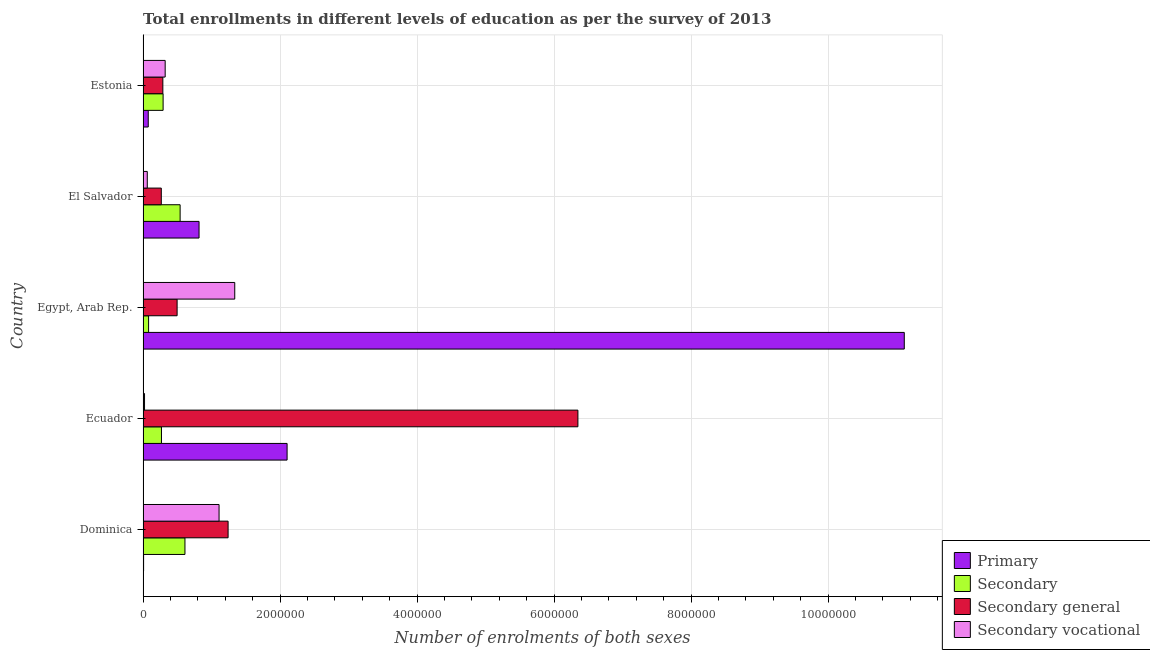Are the number of bars per tick equal to the number of legend labels?
Make the answer very short. Yes. Are the number of bars on each tick of the Y-axis equal?
Ensure brevity in your answer.  Yes. How many bars are there on the 5th tick from the bottom?
Provide a short and direct response. 4. What is the label of the 4th group of bars from the top?
Keep it short and to the point. Ecuador. What is the number of enrolments in secondary education in El Salvador?
Provide a short and direct response. 5.41e+05. Across all countries, what is the maximum number of enrolments in primary education?
Your answer should be compact. 1.11e+07. Across all countries, what is the minimum number of enrolments in secondary education?
Keep it short and to the point. 8.08e+04. In which country was the number of enrolments in secondary vocational education maximum?
Give a very brief answer. Egypt, Arab Rep. In which country was the number of enrolments in secondary education minimum?
Your response must be concise. Egypt, Arab Rep. What is the total number of enrolments in secondary general education in the graph?
Provide a short and direct response. 8.64e+06. What is the difference between the number of enrolments in primary education in Ecuador and that in Egypt, Arab Rep.?
Your answer should be compact. -9.01e+06. What is the difference between the number of enrolments in secondary vocational education in Estonia and the number of enrolments in primary education in Egypt, Arab Rep.?
Offer a terse response. -1.08e+07. What is the average number of enrolments in secondary general education per country?
Ensure brevity in your answer.  1.73e+06. What is the difference between the number of enrolments in primary education and number of enrolments in secondary vocational education in El Salvador?
Your answer should be very brief. 7.56e+05. In how many countries, is the number of enrolments in primary education greater than 8000000 ?
Your answer should be very brief. 1. What is the ratio of the number of enrolments in secondary general education in Egypt, Arab Rep. to that in El Salvador?
Provide a short and direct response. 1.87. Is the number of enrolments in secondary vocational education in Ecuador less than that in Estonia?
Your response must be concise. Yes. What is the difference between the highest and the second highest number of enrolments in secondary vocational education?
Give a very brief answer. 2.29e+05. What is the difference between the highest and the lowest number of enrolments in primary education?
Make the answer very short. 1.11e+07. In how many countries, is the number of enrolments in secondary education greater than the average number of enrolments in secondary education taken over all countries?
Offer a very short reply. 2. Is it the case that in every country, the sum of the number of enrolments in secondary education and number of enrolments in primary education is greater than the sum of number of enrolments in secondary general education and number of enrolments in secondary vocational education?
Keep it short and to the point. No. What does the 1st bar from the top in Dominica represents?
Provide a succinct answer. Secondary vocational. What does the 2nd bar from the bottom in El Salvador represents?
Provide a short and direct response. Secondary. Is it the case that in every country, the sum of the number of enrolments in primary education and number of enrolments in secondary education is greater than the number of enrolments in secondary general education?
Ensure brevity in your answer.  No. Are all the bars in the graph horizontal?
Provide a short and direct response. Yes. How many countries are there in the graph?
Make the answer very short. 5. Does the graph contain any zero values?
Your response must be concise. No. Where does the legend appear in the graph?
Provide a succinct answer. Bottom right. How many legend labels are there?
Ensure brevity in your answer.  4. How are the legend labels stacked?
Offer a terse response. Vertical. What is the title of the graph?
Give a very brief answer. Total enrollments in different levels of education as per the survey of 2013. What is the label or title of the X-axis?
Your answer should be compact. Number of enrolments of both sexes. What is the Number of enrolments of both sexes in Primary in Dominica?
Give a very brief answer. 7851. What is the Number of enrolments of both sexes of Secondary in Dominica?
Provide a succinct answer. 6.12e+05. What is the Number of enrolments of both sexes of Secondary general in Dominica?
Ensure brevity in your answer.  1.24e+06. What is the Number of enrolments of both sexes in Secondary vocational in Dominica?
Keep it short and to the point. 1.11e+06. What is the Number of enrolments of both sexes in Primary in Ecuador?
Give a very brief answer. 2.10e+06. What is the Number of enrolments of both sexes of Secondary in Ecuador?
Offer a very short reply. 2.69e+05. What is the Number of enrolments of both sexes in Secondary general in Ecuador?
Make the answer very short. 6.35e+06. What is the Number of enrolments of both sexes of Secondary vocational in Ecuador?
Offer a very short reply. 2.14e+04. What is the Number of enrolments of both sexes in Primary in Egypt, Arab Rep.?
Provide a short and direct response. 1.11e+07. What is the Number of enrolments of both sexes in Secondary in Egypt, Arab Rep.?
Provide a succinct answer. 8.08e+04. What is the Number of enrolments of both sexes in Secondary general in Egypt, Arab Rep.?
Offer a very short reply. 4.97e+05. What is the Number of enrolments of both sexes in Secondary vocational in Egypt, Arab Rep.?
Give a very brief answer. 1.34e+06. What is the Number of enrolments of both sexes of Primary in El Salvador?
Provide a short and direct response. 8.17e+05. What is the Number of enrolments of both sexes of Secondary in El Salvador?
Offer a terse response. 5.41e+05. What is the Number of enrolments of both sexes of Secondary general in El Salvador?
Keep it short and to the point. 2.66e+05. What is the Number of enrolments of both sexes in Secondary vocational in El Salvador?
Provide a succinct answer. 6.15e+04. What is the Number of enrolments of both sexes in Primary in Estonia?
Make the answer very short. 7.56e+04. What is the Number of enrolments of both sexes in Secondary in Estonia?
Your answer should be compact. 2.93e+05. What is the Number of enrolments of both sexes in Secondary general in Estonia?
Your answer should be compact. 2.89e+05. What is the Number of enrolments of both sexes in Secondary vocational in Estonia?
Provide a succinct answer. 3.23e+05. Across all countries, what is the maximum Number of enrolments of both sexes in Primary?
Your answer should be compact. 1.11e+07. Across all countries, what is the maximum Number of enrolments of both sexes of Secondary?
Offer a terse response. 6.12e+05. Across all countries, what is the maximum Number of enrolments of both sexes of Secondary general?
Offer a very short reply. 6.35e+06. Across all countries, what is the maximum Number of enrolments of both sexes of Secondary vocational?
Provide a succinct answer. 1.34e+06. Across all countries, what is the minimum Number of enrolments of both sexes of Primary?
Give a very brief answer. 7851. Across all countries, what is the minimum Number of enrolments of both sexes of Secondary?
Your answer should be very brief. 8.08e+04. Across all countries, what is the minimum Number of enrolments of both sexes in Secondary general?
Your answer should be very brief. 2.66e+05. Across all countries, what is the minimum Number of enrolments of both sexes in Secondary vocational?
Provide a succinct answer. 2.14e+04. What is the total Number of enrolments of both sexes of Primary in the graph?
Offer a terse response. 1.41e+07. What is the total Number of enrolments of both sexes of Secondary in the graph?
Provide a short and direct response. 1.79e+06. What is the total Number of enrolments of both sexes of Secondary general in the graph?
Provide a short and direct response. 8.64e+06. What is the total Number of enrolments of both sexes in Secondary vocational in the graph?
Offer a terse response. 2.85e+06. What is the difference between the Number of enrolments of both sexes in Primary in Dominica and that in Ecuador?
Your answer should be very brief. -2.09e+06. What is the difference between the Number of enrolments of both sexes of Secondary in Dominica and that in Ecuador?
Make the answer very short. 3.43e+05. What is the difference between the Number of enrolments of both sexes of Secondary general in Dominica and that in Ecuador?
Offer a terse response. -5.11e+06. What is the difference between the Number of enrolments of both sexes in Secondary vocational in Dominica and that in Ecuador?
Offer a very short reply. 1.09e+06. What is the difference between the Number of enrolments of both sexes of Primary in Dominica and that in Egypt, Arab Rep.?
Offer a very short reply. -1.11e+07. What is the difference between the Number of enrolments of both sexes of Secondary in Dominica and that in Egypt, Arab Rep.?
Offer a very short reply. 5.31e+05. What is the difference between the Number of enrolments of both sexes of Secondary general in Dominica and that in Egypt, Arab Rep.?
Offer a terse response. 7.44e+05. What is the difference between the Number of enrolments of both sexes in Secondary vocational in Dominica and that in Egypt, Arab Rep.?
Your answer should be very brief. -2.29e+05. What is the difference between the Number of enrolments of both sexes of Primary in Dominica and that in El Salvador?
Your answer should be compact. -8.09e+05. What is the difference between the Number of enrolments of both sexes in Secondary in Dominica and that in El Salvador?
Offer a very short reply. 7.06e+04. What is the difference between the Number of enrolments of both sexes of Secondary general in Dominica and that in El Salvador?
Your response must be concise. 9.75e+05. What is the difference between the Number of enrolments of both sexes of Secondary vocational in Dominica and that in El Salvador?
Provide a short and direct response. 1.05e+06. What is the difference between the Number of enrolments of both sexes of Primary in Dominica and that in Estonia?
Your response must be concise. -6.78e+04. What is the difference between the Number of enrolments of both sexes in Secondary in Dominica and that in Estonia?
Your response must be concise. 3.19e+05. What is the difference between the Number of enrolments of both sexes in Secondary general in Dominica and that in Estonia?
Your answer should be compact. 9.53e+05. What is the difference between the Number of enrolments of both sexes in Secondary vocational in Dominica and that in Estonia?
Provide a succinct answer. 7.87e+05. What is the difference between the Number of enrolments of both sexes in Primary in Ecuador and that in Egypt, Arab Rep.?
Your answer should be compact. -9.01e+06. What is the difference between the Number of enrolments of both sexes of Secondary in Ecuador and that in Egypt, Arab Rep.?
Ensure brevity in your answer.  1.88e+05. What is the difference between the Number of enrolments of both sexes of Secondary general in Ecuador and that in Egypt, Arab Rep.?
Offer a terse response. 5.85e+06. What is the difference between the Number of enrolments of both sexes of Secondary vocational in Ecuador and that in Egypt, Arab Rep.?
Your answer should be compact. -1.32e+06. What is the difference between the Number of enrolments of both sexes in Primary in Ecuador and that in El Salvador?
Offer a very short reply. 1.29e+06. What is the difference between the Number of enrolments of both sexes of Secondary in Ecuador and that in El Salvador?
Provide a short and direct response. -2.72e+05. What is the difference between the Number of enrolments of both sexes in Secondary general in Ecuador and that in El Salvador?
Provide a succinct answer. 6.08e+06. What is the difference between the Number of enrolments of both sexes of Secondary vocational in Ecuador and that in El Salvador?
Offer a terse response. -4.01e+04. What is the difference between the Number of enrolments of both sexes of Primary in Ecuador and that in Estonia?
Ensure brevity in your answer.  2.03e+06. What is the difference between the Number of enrolments of both sexes in Secondary in Ecuador and that in Estonia?
Make the answer very short. -2.40e+04. What is the difference between the Number of enrolments of both sexes in Secondary general in Ecuador and that in Estonia?
Your response must be concise. 6.06e+06. What is the difference between the Number of enrolments of both sexes of Secondary vocational in Ecuador and that in Estonia?
Make the answer very short. -3.01e+05. What is the difference between the Number of enrolments of both sexes in Primary in Egypt, Arab Rep. and that in El Salvador?
Your answer should be compact. 1.03e+07. What is the difference between the Number of enrolments of both sexes in Secondary in Egypt, Arab Rep. and that in El Salvador?
Your answer should be compact. -4.60e+05. What is the difference between the Number of enrolments of both sexes in Secondary general in Egypt, Arab Rep. and that in El Salvador?
Give a very brief answer. 2.31e+05. What is the difference between the Number of enrolments of both sexes of Secondary vocational in Egypt, Arab Rep. and that in El Salvador?
Your answer should be very brief. 1.28e+06. What is the difference between the Number of enrolments of both sexes of Primary in Egypt, Arab Rep. and that in Estonia?
Your response must be concise. 1.10e+07. What is the difference between the Number of enrolments of both sexes in Secondary in Egypt, Arab Rep. and that in Estonia?
Offer a terse response. -2.12e+05. What is the difference between the Number of enrolments of both sexes in Secondary general in Egypt, Arab Rep. and that in Estonia?
Give a very brief answer. 2.08e+05. What is the difference between the Number of enrolments of both sexes in Secondary vocational in Egypt, Arab Rep. and that in Estonia?
Offer a very short reply. 1.02e+06. What is the difference between the Number of enrolments of both sexes of Primary in El Salvador and that in Estonia?
Give a very brief answer. 7.42e+05. What is the difference between the Number of enrolments of both sexes of Secondary in El Salvador and that in Estonia?
Offer a terse response. 2.48e+05. What is the difference between the Number of enrolments of both sexes in Secondary general in El Salvador and that in Estonia?
Provide a short and direct response. -2.27e+04. What is the difference between the Number of enrolments of both sexes of Secondary vocational in El Salvador and that in Estonia?
Provide a succinct answer. -2.61e+05. What is the difference between the Number of enrolments of both sexes in Primary in Dominica and the Number of enrolments of both sexes in Secondary in Ecuador?
Your answer should be very brief. -2.61e+05. What is the difference between the Number of enrolments of both sexes in Primary in Dominica and the Number of enrolments of both sexes in Secondary general in Ecuador?
Your response must be concise. -6.34e+06. What is the difference between the Number of enrolments of both sexes in Primary in Dominica and the Number of enrolments of both sexes in Secondary vocational in Ecuador?
Your answer should be very brief. -1.35e+04. What is the difference between the Number of enrolments of both sexes of Secondary in Dominica and the Number of enrolments of both sexes of Secondary general in Ecuador?
Ensure brevity in your answer.  -5.74e+06. What is the difference between the Number of enrolments of both sexes in Secondary in Dominica and the Number of enrolments of both sexes in Secondary vocational in Ecuador?
Ensure brevity in your answer.  5.90e+05. What is the difference between the Number of enrolments of both sexes of Secondary general in Dominica and the Number of enrolments of both sexes of Secondary vocational in Ecuador?
Offer a terse response. 1.22e+06. What is the difference between the Number of enrolments of both sexes in Primary in Dominica and the Number of enrolments of both sexes in Secondary in Egypt, Arab Rep.?
Ensure brevity in your answer.  -7.30e+04. What is the difference between the Number of enrolments of both sexes in Primary in Dominica and the Number of enrolments of both sexes in Secondary general in Egypt, Arab Rep.?
Provide a succinct answer. -4.89e+05. What is the difference between the Number of enrolments of both sexes of Primary in Dominica and the Number of enrolments of both sexes of Secondary vocational in Egypt, Arab Rep.?
Your answer should be very brief. -1.33e+06. What is the difference between the Number of enrolments of both sexes in Secondary in Dominica and the Number of enrolments of both sexes in Secondary general in Egypt, Arab Rep.?
Your response must be concise. 1.15e+05. What is the difference between the Number of enrolments of both sexes of Secondary in Dominica and the Number of enrolments of both sexes of Secondary vocational in Egypt, Arab Rep.?
Your response must be concise. -7.27e+05. What is the difference between the Number of enrolments of both sexes of Secondary general in Dominica and the Number of enrolments of both sexes of Secondary vocational in Egypt, Arab Rep.?
Keep it short and to the point. -9.71e+04. What is the difference between the Number of enrolments of both sexes in Primary in Dominica and the Number of enrolments of both sexes in Secondary in El Salvador?
Ensure brevity in your answer.  -5.33e+05. What is the difference between the Number of enrolments of both sexes in Primary in Dominica and the Number of enrolments of both sexes in Secondary general in El Salvador?
Give a very brief answer. -2.58e+05. What is the difference between the Number of enrolments of both sexes in Primary in Dominica and the Number of enrolments of both sexes in Secondary vocational in El Salvador?
Your answer should be compact. -5.36e+04. What is the difference between the Number of enrolments of both sexes of Secondary in Dominica and the Number of enrolments of both sexes of Secondary general in El Salvador?
Your answer should be very brief. 3.45e+05. What is the difference between the Number of enrolments of both sexes in Secondary in Dominica and the Number of enrolments of both sexes in Secondary vocational in El Salvador?
Make the answer very short. 5.50e+05. What is the difference between the Number of enrolments of both sexes in Secondary general in Dominica and the Number of enrolments of both sexes in Secondary vocational in El Salvador?
Offer a terse response. 1.18e+06. What is the difference between the Number of enrolments of both sexes of Primary in Dominica and the Number of enrolments of both sexes of Secondary in Estonia?
Offer a very short reply. -2.85e+05. What is the difference between the Number of enrolments of both sexes in Primary in Dominica and the Number of enrolments of both sexes in Secondary general in Estonia?
Keep it short and to the point. -2.81e+05. What is the difference between the Number of enrolments of both sexes of Primary in Dominica and the Number of enrolments of both sexes of Secondary vocational in Estonia?
Offer a terse response. -3.15e+05. What is the difference between the Number of enrolments of both sexes of Secondary in Dominica and the Number of enrolments of both sexes of Secondary general in Estonia?
Ensure brevity in your answer.  3.23e+05. What is the difference between the Number of enrolments of both sexes of Secondary in Dominica and the Number of enrolments of both sexes of Secondary vocational in Estonia?
Keep it short and to the point. 2.89e+05. What is the difference between the Number of enrolments of both sexes of Secondary general in Dominica and the Number of enrolments of both sexes of Secondary vocational in Estonia?
Make the answer very short. 9.19e+05. What is the difference between the Number of enrolments of both sexes in Primary in Ecuador and the Number of enrolments of both sexes in Secondary in Egypt, Arab Rep.?
Keep it short and to the point. 2.02e+06. What is the difference between the Number of enrolments of both sexes in Primary in Ecuador and the Number of enrolments of both sexes in Secondary general in Egypt, Arab Rep.?
Offer a terse response. 1.61e+06. What is the difference between the Number of enrolments of both sexes in Primary in Ecuador and the Number of enrolments of both sexes in Secondary vocational in Egypt, Arab Rep.?
Your response must be concise. 7.64e+05. What is the difference between the Number of enrolments of both sexes of Secondary in Ecuador and the Number of enrolments of both sexes of Secondary general in Egypt, Arab Rep.?
Provide a short and direct response. -2.28e+05. What is the difference between the Number of enrolments of both sexes in Secondary in Ecuador and the Number of enrolments of both sexes in Secondary vocational in Egypt, Arab Rep.?
Offer a very short reply. -1.07e+06. What is the difference between the Number of enrolments of both sexes of Secondary general in Ecuador and the Number of enrolments of both sexes of Secondary vocational in Egypt, Arab Rep.?
Offer a terse response. 5.01e+06. What is the difference between the Number of enrolments of both sexes in Primary in Ecuador and the Number of enrolments of both sexes in Secondary in El Salvador?
Provide a succinct answer. 1.56e+06. What is the difference between the Number of enrolments of both sexes in Primary in Ecuador and the Number of enrolments of both sexes in Secondary general in El Salvador?
Keep it short and to the point. 1.84e+06. What is the difference between the Number of enrolments of both sexes in Primary in Ecuador and the Number of enrolments of both sexes in Secondary vocational in El Salvador?
Provide a succinct answer. 2.04e+06. What is the difference between the Number of enrolments of both sexes of Secondary in Ecuador and the Number of enrolments of both sexes of Secondary general in El Salvador?
Provide a short and direct response. 2470. What is the difference between the Number of enrolments of both sexes of Secondary in Ecuador and the Number of enrolments of both sexes of Secondary vocational in El Salvador?
Make the answer very short. 2.07e+05. What is the difference between the Number of enrolments of both sexes of Secondary general in Ecuador and the Number of enrolments of both sexes of Secondary vocational in El Salvador?
Offer a terse response. 6.29e+06. What is the difference between the Number of enrolments of both sexes of Primary in Ecuador and the Number of enrolments of both sexes of Secondary in Estonia?
Your response must be concise. 1.81e+06. What is the difference between the Number of enrolments of both sexes in Primary in Ecuador and the Number of enrolments of both sexes in Secondary general in Estonia?
Make the answer very short. 1.81e+06. What is the difference between the Number of enrolments of both sexes of Primary in Ecuador and the Number of enrolments of both sexes of Secondary vocational in Estonia?
Your answer should be very brief. 1.78e+06. What is the difference between the Number of enrolments of both sexes in Secondary in Ecuador and the Number of enrolments of both sexes in Secondary general in Estonia?
Provide a succinct answer. -2.02e+04. What is the difference between the Number of enrolments of both sexes of Secondary in Ecuador and the Number of enrolments of both sexes of Secondary vocational in Estonia?
Offer a very short reply. -5.41e+04. What is the difference between the Number of enrolments of both sexes of Secondary general in Ecuador and the Number of enrolments of both sexes of Secondary vocational in Estonia?
Ensure brevity in your answer.  6.03e+06. What is the difference between the Number of enrolments of both sexes in Primary in Egypt, Arab Rep. and the Number of enrolments of both sexes in Secondary in El Salvador?
Make the answer very short. 1.06e+07. What is the difference between the Number of enrolments of both sexes in Primary in Egypt, Arab Rep. and the Number of enrolments of both sexes in Secondary general in El Salvador?
Your response must be concise. 1.08e+07. What is the difference between the Number of enrolments of both sexes in Primary in Egypt, Arab Rep. and the Number of enrolments of both sexes in Secondary vocational in El Salvador?
Offer a terse response. 1.11e+07. What is the difference between the Number of enrolments of both sexes of Secondary in Egypt, Arab Rep. and the Number of enrolments of both sexes of Secondary general in El Salvador?
Offer a very short reply. -1.85e+05. What is the difference between the Number of enrolments of both sexes in Secondary in Egypt, Arab Rep. and the Number of enrolments of both sexes in Secondary vocational in El Salvador?
Provide a short and direct response. 1.93e+04. What is the difference between the Number of enrolments of both sexes in Secondary general in Egypt, Arab Rep. and the Number of enrolments of both sexes in Secondary vocational in El Salvador?
Provide a succinct answer. 4.36e+05. What is the difference between the Number of enrolments of both sexes of Primary in Egypt, Arab Rep. and the Number of enrolments of both sexes of Secondary in Estonia?
Keep it short and to the point. 1.08e+07. What is the difference between the Number of enrolments of both sexes of Primary in Egypt, Arab Rep. and the Number of enrolments of both sexes of Secondary general in Estonia?
Provide a short and direct response. 1.08e+07. What is the difference between the Number of enrolments of both sexes in Primary in Egypt, Arab Rep. and the Number of enrolments of both sexes in Secondary vocational in Estonia?
Provide a short and direct response. 1.08e+07. What is the difference between the Number of enrolments of both sexes in Secondary in Egypt, Arab Rep. and the Number of enrolments of both sexes in Secondary general in Estonia?
Provide a short and direct response. -2.08e+05. What is the difference between the Number of enrolments of both sexes in Secondary in Egypt, Arab Rep. and the Number of enrolments of both sexes in Secondary vocational in Estonia?
Your answer should be compact. -2.42e+05. What is the difference between the Number of enrolments of both sexes of Secondary general in Egypt, Arab Rep. and the Number of enrolments of both sexes of Secondary vocational in Estonia?
Your answer should be compact. 1.74e+05. What is the difference between the Number of enrolments of both sexes in Primary in El Salvador and the Number of enrolments of both sexes in Secondary in Estonia?
Provide a succinct answer. 5.25e+05. What is the difference between the Number of enrolments of both sexes in Primary in El Salvador and the Number of enrolments of both sexes in Secondary general in Estonia?
Give a very brief answer. 5.28e+05. What is the difference between the Number of enrolments of both sexes of Primary in El Salvador and the Number of enrolments of both sexes of Secondary vocational in Estonia?
Ensure brevity in your answer.  4.95e+05. What is the difference between the Number of enrolments of both sexes of Secondary in El Salvador and the Number of enrolments of both sexes of Secondary general in Estonia?
Keep it short and to the point. 2.52e+05. What is the difference between the Number of enrolments of both sexes in Secondary in El Salvador and the Number of enrolments of both sexes in Secondary vocational in Estonia?
Ensure brevity in your answer.  2.18e+05. What is the difference between the Number of enrolments of both sexes in Secondary general in El Salvador and the Number of enrolments of both sexes in Secondary vocational in Estonia?
Ensure brevity in your answer.  -5.65e+04. What is the average Number of enrolments of both sexes in Primary per country?
Keep it short and to the point. 2.82e+06. What is the average Number of enrolments of both sexes of Secondary per country?
Offer a terse response. 3.59e+05. What is the average Number of enrolments of both sexes in Secondary general per country?
Your response must be concise. 1.73e+06. What is the average Number of enrolments of both sexes in Secondary vocational per country?
Offer a terse response. 5.71e+05. What is the difference between the Number of enrolments of both sexes of Primary and Number of enrolments of both sexes of Secondary in Dominica?
Provide a succinct answer. -6.04e+05. What is the difference between the Number of enrolments of both sexes of Primary and Number of enrolments of both sexes of Secondary general in Dominica?
Your response must be concise. -1.23e+06. What is the difference between the Number of enrolments of both sexes of Primary and Number of enrolments of both sexes of Secondary vocational in Dominica?
Provide a succinct answer. -1.10e+06. What is the difference between the Number of enrolments of both sexes in Secondary and Number of enrolments of both sexes in Secondary general in Dominica?
Ensure brevity in your answer.  -6.30e+05. What is the difference between the Number of enrolments of both sexes of Secondary and Number of enrolments of both sexes of Secondary vocational in Dominica?
Your response must be concise. -4.98e+05. What is the difference between the Number of enrolments of both sexes in Secondary general and Number of enrolments of both sexes in Secondary vocational in Dominica?
Offer a very short reply. 1.32e+05. What is the difference between the Number of enrolments of both sexes in Primary and Number of enrolments of both sexes in Secondary in Ecuador?
Provide a succinct answer. 1.83e+06. What is the difference between the Number of enrolments of both sexes in Primary and Number of enrolments of both sexes in Secondary general in Ecuador?
Give a very brief answer. -4.25e+06. What is the difference between the Number of enrolments of both sexes of Primary and Number of enrolments of both sexes of Secondary vocational in Ecuador?
Your answer should be very brief. 2.08e+06. What is the difference between the Number of enrolments of both sexes in Secondary and Number of enrolments of both sexes in Secondary general in Ecuador?
Offer a very short reply. -6.08e+06. What is the difference between the Number of enrolments of both sexes in Secondary and Number of enrolments of both sexes in Secondary vocational in Ecuador?
Make the answer very short. 2.47e+05. What is the difference between the Number of enrolments of both sexes in Secondary general and Number of enrolments of both sexes in Secondary vocational in Ecuador?
Provide a short and direct response. 6.33e+06. What is the difference between the Number of enrolments of both sexes of Primary and Number of enrolments of both sexes of Secondary in Egypt, Arab Rep.?
Keep it short and to the point. 1.10e+07. What is the difference between the Number of enrolments of both sexes in Primary and Number of enrolments of both sexes in Secondary general in Egypt, Arab Rep.?
Provide a succinct answer. 1.06e+07. What is the difference between the Number of enrolments of both sexes of Primary and Number of enrolments of both sexes of Secondary vocational in Egypt, Arab Rep.?
Keep it short and to the point. 9.77e+06. What is the difference between the Number of enrolments of both sexes in Secondary and Number of enrolments of both sexes in Secondary general in Egypt, Arab Rep.?
Your response must be concise. -4.16e+05. What is the difference between the Number of enrolments of both sexes of Secondary and Number of enrolments of both sexes of Secondary vocational in Egypt, Arab Rep.?
Make the answer very short. -1.26e+06. What is the difference between the Number of enrolments of both sexes in Secondary general and Number of enrolments of both sexes in Secondary vocational in Egypt, Arab Rep.?
Keep it short and to the point. -8.41e+05. What is the difference between the Number of enrolments of both sexes in Primary and Number of enrolments of both sexes in Secondary in El Salvador?
Give a very brief answer. 2.76e+05. What is the difference between the Number of enrolments of both sexes in Primary and Number of enrolments of both sexes in Secondary general in El Salvador?
Ensure brevity in your answer.  5.51e+05. What is the difference between the Number of enrolments of both sexes of Primary and Number of enrolments of both sexes of Secondary vocational in El Salvador?
Your response must be concise. 7.56e+05. What is the difference between the Number of enrolments of both sexes in Secondary and Number of enrolments of both sexes in Secondary general in El Salvador?
Make the answer very short. 2.75e+05. What is the difference between the Number of enrolments of both sexes in Secondary and Number of enrolments of both sexes in Secondary vocational in El Salvador?
Your answer should be compact. 4.80e+05. What is the difference between the Number of enrolments of both sexes of Secondary general and Number of enrolments of both sexes of Secondary vocational in El Salvador?
Your answer should be compact. 2.05e+05. What is the difference between the Number of enrolments of both sexes of Primary and Number of enrolments of both sexes of Secondary in Estonia?
Offer a very short reply. -2.17e+05. What is the difference between the Number of enrolments of both sexes in Primary and Number of enrolments of both sexes in Secondary general in Estonia?
Provide a short and direct response. -2.13e+05. What is the difference between the Number of enrolments of both sexes of Primary and Number of enrolments of both sexes of Secondary vocational in Estonia?
Your answer should be compact. -2.47e+05. What is the difference between the Number of enrolments of both sexes of Secondary and Number of enrolments of both sexes of Secondary general in Estonia?
Your answer should be very brief. 3766. What is the difference between the Number of enrolments of both sexes of Secondary and Number of enrolments of both sexes of Secondary vocational in Estonia?
Your response must be concise. -3.01e+04. What is the difference between the Number of enrolments of both sexes in Secondary general and Number of enrolments of both sexes in Secondary vocational in Estonia?
Provide a succinct answer. -3.39e+04. What is the ratio of the Number of enrolments of both sexes of Primary in Dominica to that in Ecuador?
Your answer should be compact. 0. What is the ratio of the Number of enrolments of both sexes of Secondary in Dominica to that in Ecuador?
Make the answer very short. 2.28. What is the ratio of the Number of enrolments of both sexes of Secondary general in Dominica to that in Ecuador?
Ensure brevity in your answer.  0.2. What is the ratio of the Number of enrolments of both sexes of Secondary vocational in Dominica to that in Ecuador?
Keep it short and to the point. 51.97. What is the ratio of the Number of enrolments of both sexes in Primary in Dominica to that in Egypt, Arab Rep.?
Provide a succinct answer. 0. What is the ratio of the Number of enrolments of both sexes in Secondary in Dominica to that in Egypt, Arab Rep.?
Your response must be concise. 7.57. What is the ratio of the Number of enrolments of both sexes in Secondary general in Dominica to that in Egypt, Arab Rep.?
Offer a terse response. 2.5. What is the ratio of the Number of enrolments of both sexes of Secondary vocational in Dominica to that in Egypt, Arab Rep.?
Provide a succinct answer. 0.83. What is the ratio of the Number of enrolments of both sexes in Primary in Dominica to that in El Salvador?
Offer a very short reply. 0.01. What is the ratio of the Number of enrolments of both sexes in Secondary in Dominica to that in El Salvador?
Your answer should be very brief. 1.13. What is the ratio of the Number of enrolments of both sexes of Secondary general in Dominica to that in El Salvador?
Your answer should be compact. 4.66. What is the ratio of the Number of enrolments of both sexes of Secondary vocational in Dominica to that in El Salvador?
Offer a terse response. 18.04. What is the ratio of the Number of enrolments of both sexes in Primary in Dominica to that in Estonia?
Your answer should be compact. 0.1. What is the ratio of the Number of enrolments of both sexes of Secondary in Dominica to that in Estonia?
Your answer should be very brief. 2.09. What is the ratio of the Number of enrolments of both sexes of Secondary general in Dominica to that in Estonia?
Your answer should be very brief. 4.3. What is the ratio of the Number of enrolments of both sexes of Secondary vocational in Dominica to that in Estonia?
Keep it short and to the point. 3.44. What is the ratio of the Number of enrolments of both sexes of Primary in Ecuador to that in Egypt, Arab Rep.?
Ensure brevity in your answer.  0.19. What is the ratio of the Number of enrolments of both sexes of Secondary in Ecuador to that in Egypt, Arab Rep.?
Offer a very short reply. 3.32. What is the ratio of the Number of enrolments of both sexes in Secondary general in Ecuador to that in Egypt, Arab Rep.?
Your answer should be compact. 12.77. What is the ratio of the Number of enrolments of both sexes in Secondary vocational in Ecuador to that in Egypt, Arab Rep.?
Offer a terse response. 0.02. What is the ratio of the Number of enrolments of both sexes in Primary in Ecuador to that in El Salvador?
Your answer should be compact. 2.57. What is the ratio of the Number of enrolments of both sexes in Secondary in Ecuador to that in El Salvador?
Make the answer very short. 0.5. What is the ratio of the Number of enrolments of both sexes of Secondary general in Ecuador to that in El Salvador?
Provide a short and direct response. 23.85. What is the ratio of the Number of enrolments of both sexes in Secondary vocational in Ecuador to that in El Salvador?
Make the answer very short. 0.35. What is the ratio of the Number of enrolments of both sexes in Primary in Ecuador to that in Estonia?
Provide a short and direct response. 27.8. What is the ratio of the Number of enrolments of both sexes in Secondary in Ecuador to that in Estonia?
Your response must be concise. 0.92. What is the ratio of the Number of enrolments of both sexes of Secondary general in Ecuador to that in Estonia?
Ensure brevity in your answer.  21.98. What is the ratio of the Number of enrolments of both sexes of Secondary vocational in Ecuador to that in Estonia?
Provide a short and direct response. 0.07. What is the ratio of the Number of enrolments of both sexes in Primary in Egypt, Arab Rep. to that in El Salvador?
Provide a short and direct response. 13.6. What is the ratio of the Number of enrolments of both sexes of Secondary in Egypt, Arab Rep. to that in El Salvador?
Make the answer very short. 0.15. What is the ratio of the Number of enrolments of both sexes in Secondary general in Egypt, Arab Rep. to that in El Salvador?
Your answer should be very brief. 1.87. What is the ratio of the Number of enrolments of both sexes in Secondary vocational in Egypt, Arab Rep. to that in El Salvador?
Provide a short and direct response. 21.77. What is the ratio of the Number of enrolments of both sexes of Primary in Egypt, Arab Rep. to that in Estonia?
Offer a very short reply. 146.91. What is the ratio of the Number of enrolments of both sexes of Secondary in Egypt, Arab Rep. to that in Estonia?
Offer a very short reply. 0.28. What is the ratio of the Number of enrolments of both sexes of Secondary general in Egypt, Arab Rep. to that in Estonia?
Offer a very short reply. 1.72. What is the ratio of the Number of enrolments of both sexes of Secondary vocational in Egypt, Arab Rep. to that in Estonia?
Make the answer very short. 4.15. What is the ratio of the Number of enrolments of both sexes in Primary in El Salvador to that in Estonia?
Offer a very short reply. 10.8. What is the ratio of the Number of enrolments of both sexes in Secondary in El Salvador to that in Estonia?
Give a very brief answer. 1.85. What is the ratio of the Number of enrolments of both sexes in Secondary general in El Salvador to that in Estonia?
Provide a short and direct response. 0.92. What is the ratio of the Number of enrolments of both sexes of Secondary vocational in El Salvador to that in Estonia?
Offer a very short reply. 0.19. What is the difference between the highest and the second highest Number of enrolments of both sexes in Primary?
Offer a very short reply. 9.01e+06. What is the difference between the highest and the second highest Number of enrolments of both sexes in Secondary?
Your response must be concise. 7.06e+04. What is the difference between the highest and the second highest Number of enrolments of both sexes in Secondary general?
Offer a very short reply. 5.11e+06. What is the difference between the highest and the second highest Number of enrolments of both sexes in Secondary vocational?
Provide a short and direct response. 2.29e+05. What is the difference between the highest and the lowest Number of enrolments of both sexes of Primary?
Provide a succinct answer. 1.11e+07. What is the difference between the highest and the lowest Number of enrolments of both sexes in Secondary?
Make the answer very short. 5.31e+05. What is the difference between the highest and the lowest Number of enrolments of both sexes of Secondary general?
Provide a short and direct response. 6.08e+06. What is the difference between the highest and the lowest Number of enrolments of both sexes in Secondary vocational?
Your answer should be compact. 1.32e+06. 